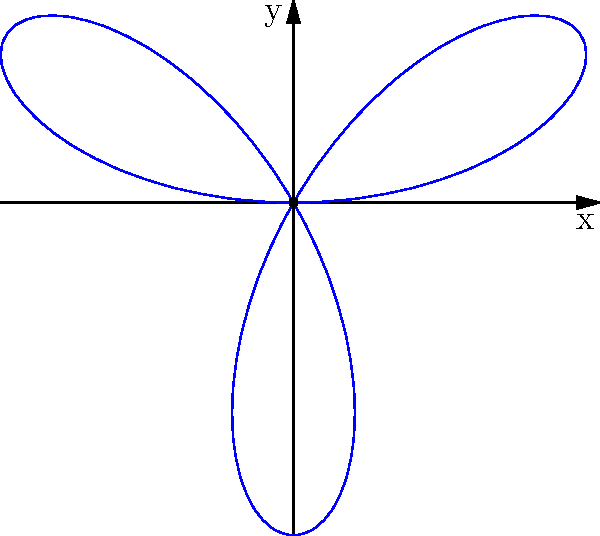In religious symbolism, the lotus flower often represents purity and spiritual awakening. A rose curve with the polar equation $r = 2\sin(3\theta)$ is used to model the petals of a lotus flower. Calculate the area enclosed by this curve, which represents the spiritual space within the lotus blossom. To find the area enclosed by the rose curve, we'll follow these steps:

1) The general formula for the area enclosed by a polar curve is:
   $$A = \frac{1}{2} \int_{0}^{2\pi} r^2(\theta) d\theta$$

2) In this case, $r(\theta) = 2\sin(3\theta)$, so we need to calculate:
   $$A = \frac{1}{2} \int_{0}^{2\pi} (2\sin(3\theta))^2 d\theta$$

3) Simplify the integrand:
   $$A = \frac{1}{2} \int_{0}^{2\pi} 4\sin^2(3\theta) d\theta$$

4) Use the trigonometric identity $\sin^2(x) = \frac{1 - \cos(2x)}{2}$:
   $$A = \frac{1}{2} \int_{0}^{2\pi} 4 \cdot \frac{1 - \cos(6\theta)}{2} d\theta$$

5) Simplify:
   $$A = \int_{0}^{2\pi} (1 - \cos(6\theta)) d\theta$$

6) Integrate:
   $$A = [\theta - \frac{1}{6}\sin(6\theta)]_{0}^{2\pi}$$

7) Evaluate the definite integral:
   $$A = (2\pi - 0) - (\frac{1}{6}\sin(12\pi) - \frac{1}{6}\sin(0)) = 2\pi$$

Therefore, the area enclosed by the rose curve is $2\pi$ square units.
Answer: $2\pi$ square units 